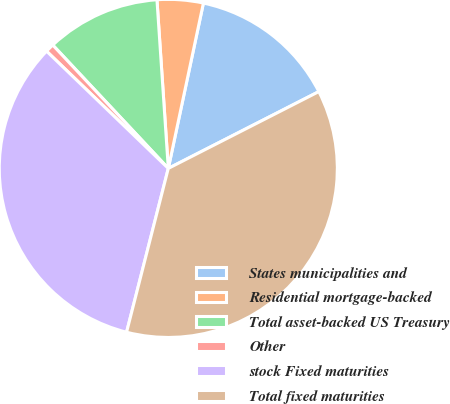<chart> <loc_0><loc_0><loc_500><loc_500><pie_chart><fcel>States municipalities and<fcel>Residential mortgage-backed<fcel>Total asset-backed US Treasury<fcel>Other<fcel>stock Fixed maturities<fcel>Total fixed maturities<nl><fcel>14.16%<fcel>4.4%<fcel>10.91%<fcel>0.82%<fcel>33.23%<fcel>36.48%<nl></chart> 